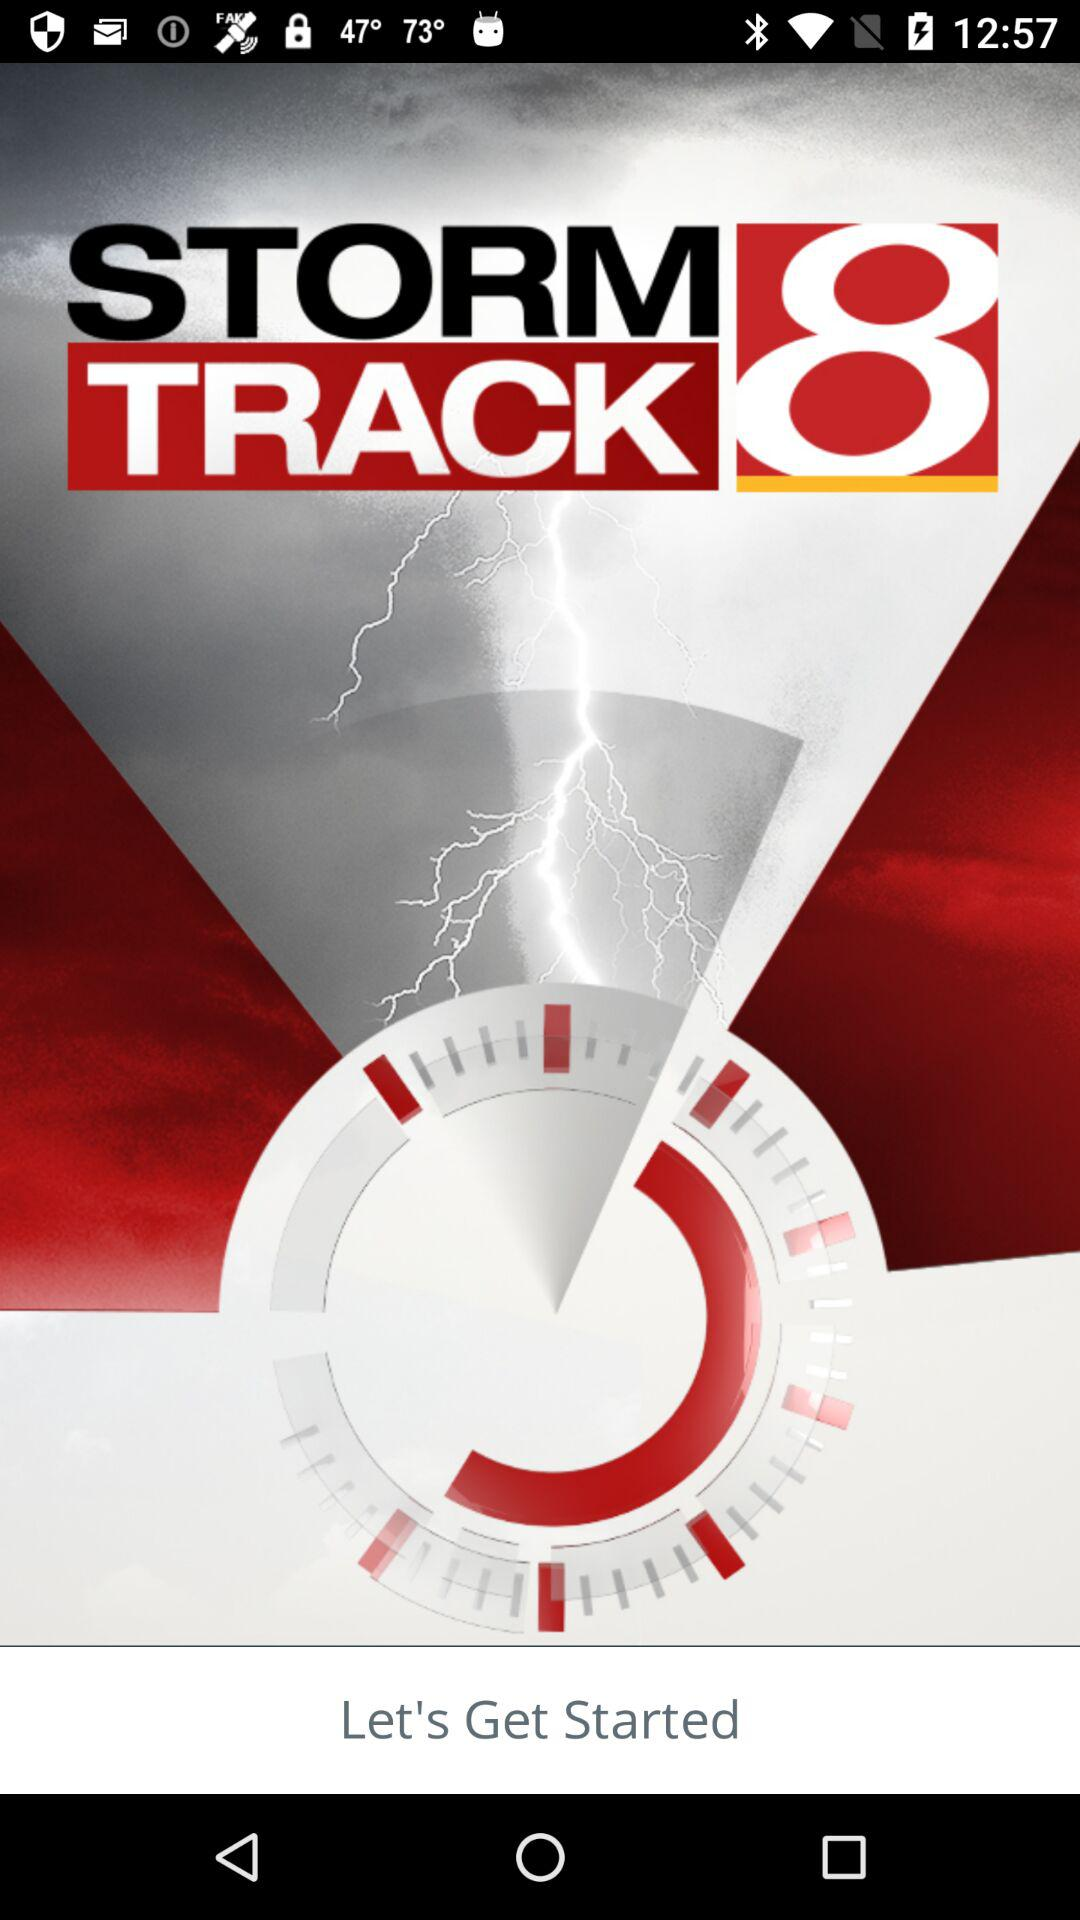What is the name of the application? The name of the application is "Storm Track 8". 